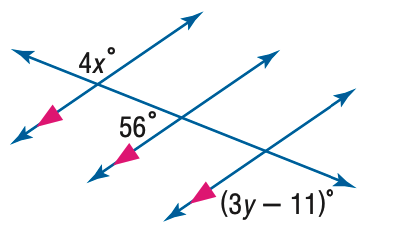Question: Find y in the figure.
Choices:
A. 31
B. 45
C. 56
D. 75
Answer with the letter. Answer: B Question: Find x in the figure.
Choices:
A. 14
B. 31
C. 45
D. 56
Answer with the letter. Answer: B 